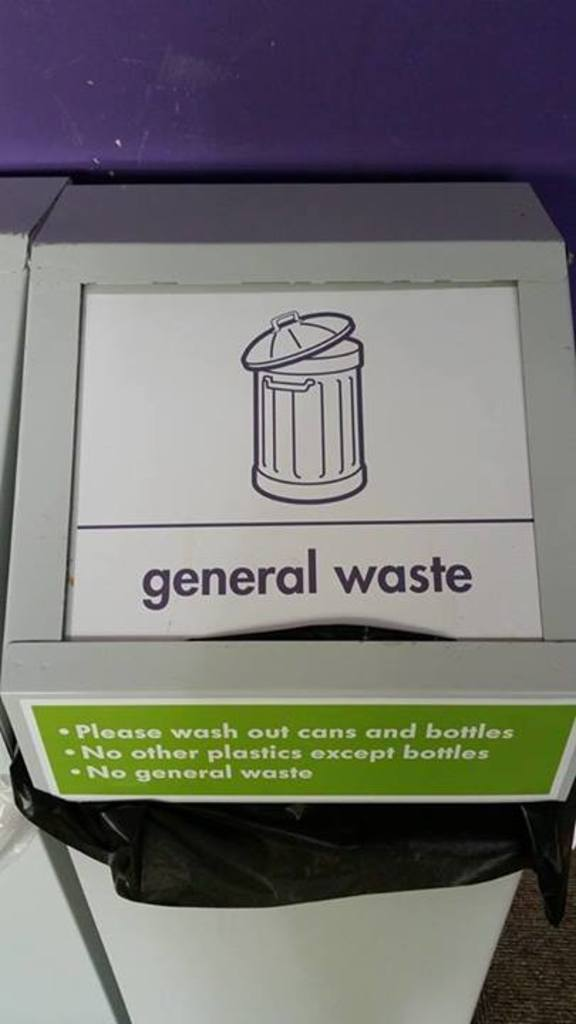Can you explain why it says 'no general waste' on a bin labeled 'general waste'? The bin is specially designated for specific recyclable items, primarily cans and bottles, which often get thrown in general waste. By stating 'no general waste,' the label aims to prevent contamination of these recyclables with other non-recyclable waste, ensuring they remain suitable for recycling processes. 